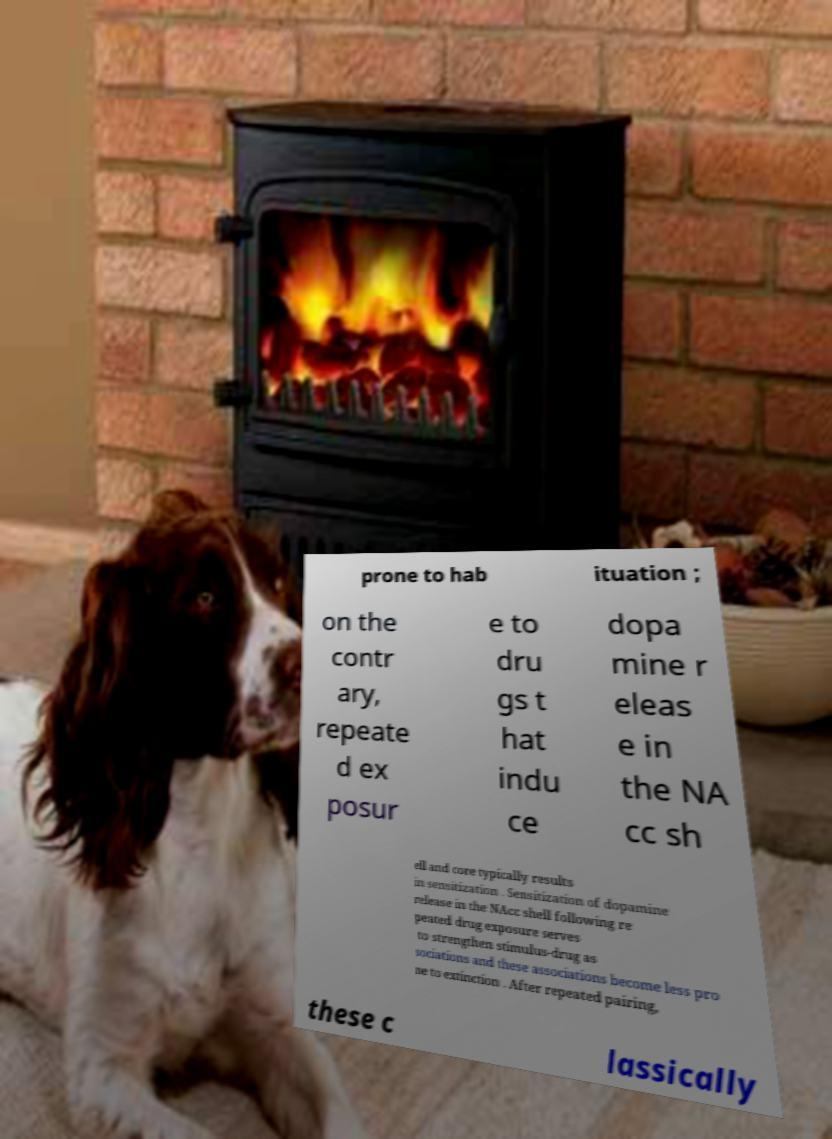There's text embedded in this image that I need extracted. Can you transcribe it verbatim? prone to hab ituation ; on the contr ary, repeate d ex posur e to dru gs t hat indu ce dopa mine r eleas e in the NA cc sh ell and core typically results in sensitization . Sensitization of dopamine release in the NAcc shell following re peated drug exposure serves to strengthen stimulus-drug as sociations and these associations become less pro ne to extinction . After repeated pairing, these c lassically 